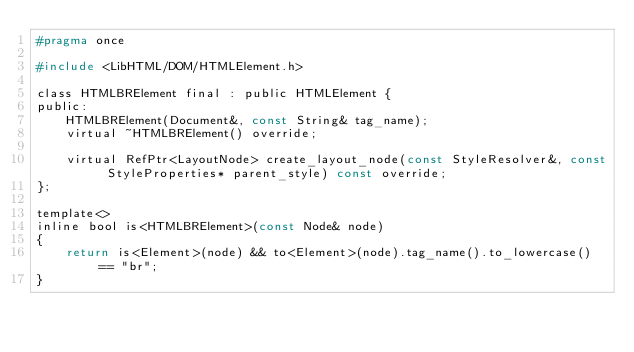Convert code to text. <code><loc_0><loc_0><loc_500><loc_500><_C_>#pragma once

#include <LibHTML/DOM/HTMLElement.h>

class HTMLBRElement final : public HTMLElement {
public:
    HTMLBRElement(Document&, const String& tag_name);
    virtual ~HTMLBRElement() override;

    virtual RefPtr<LayoutNode> create_layout_node(const StyleResolver&, const StyleProperties* parent_style) const override;
};

template<>
inline bool is<HTMLBRElement>(const Node& node)
{
    return is<Element>(node) && to<Element>(node).tag_name().to_lowercase() == "br";
}
</code> 